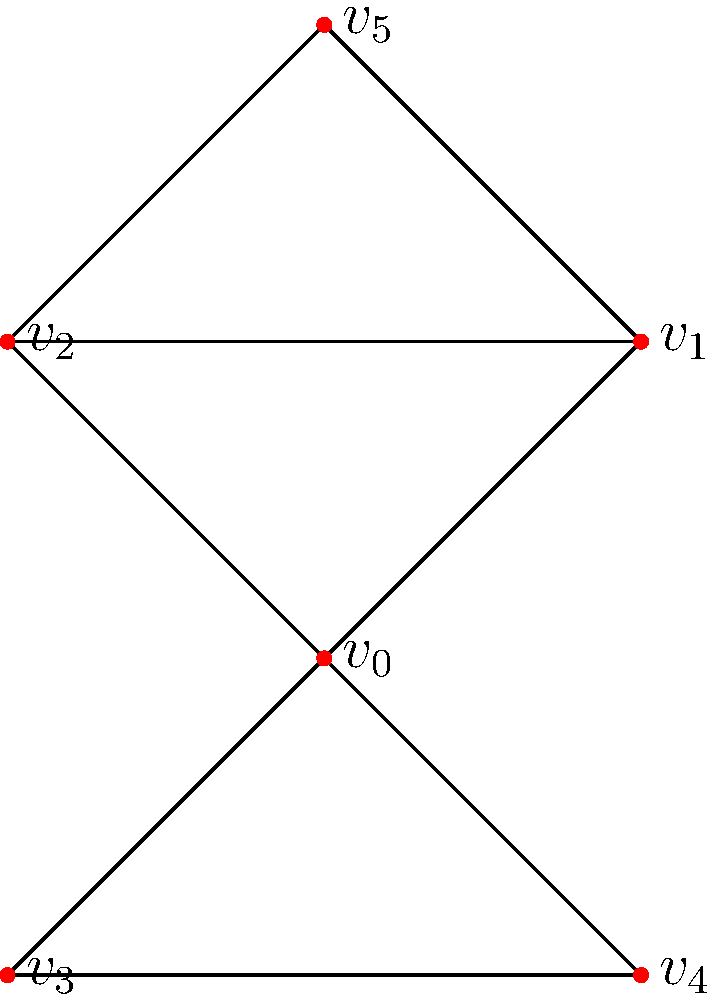In the given social network graph representing scientific collaborations, which vertex has the highest degree centrality? How does this relate to the vertex's potential influence in the scientific community? To determine the vertex with the highest degree centrality and its implications, we'll follow these steps:

1. Calculate the degree of each vertex:
   $v_0$: 4 connections
   $v_1$: 3 connections
   $v_2$: 3 connections
   $v_3$: 2 connections
   $v_4$: 2 connections
   $v_5$: 2 connections

2. Identify the highest degree:
   $v_0$ has the highest degree with 4 connections.

3. Interpret the result:
   Degree centrality measures the number of direct connections a node has in the network. In the context of scientific collaborations, a higher degree centrality suggests:

   a) More collaborative relationships
   b) Greater access to information and resources
   c) Potentially higher influence in the scientific community

4. Implications for $v_0$:
   - Acts as a hub for information exchange
   - May have a broader perspective on research trends
   - Likely to have more opportunities for interdisciplinary work
   - Could play a crucial role in disseminating new ideas or methodologies

5. Limitations to consider:
   - Degree centrality doesn't account for the quality or impact of collaborations
   - Other centrality measures (e.g., betweenness, closeness) might provide additional insights

In the context of societal change, researchers with high degree centrality may be more likely to bridge different scientific paradigms and facilitate the spread of new ideas across disciplines.
Answer: $v_0$ has the highest degree centrality, indicating potential for greater influence and information exchange in the scientific community. 